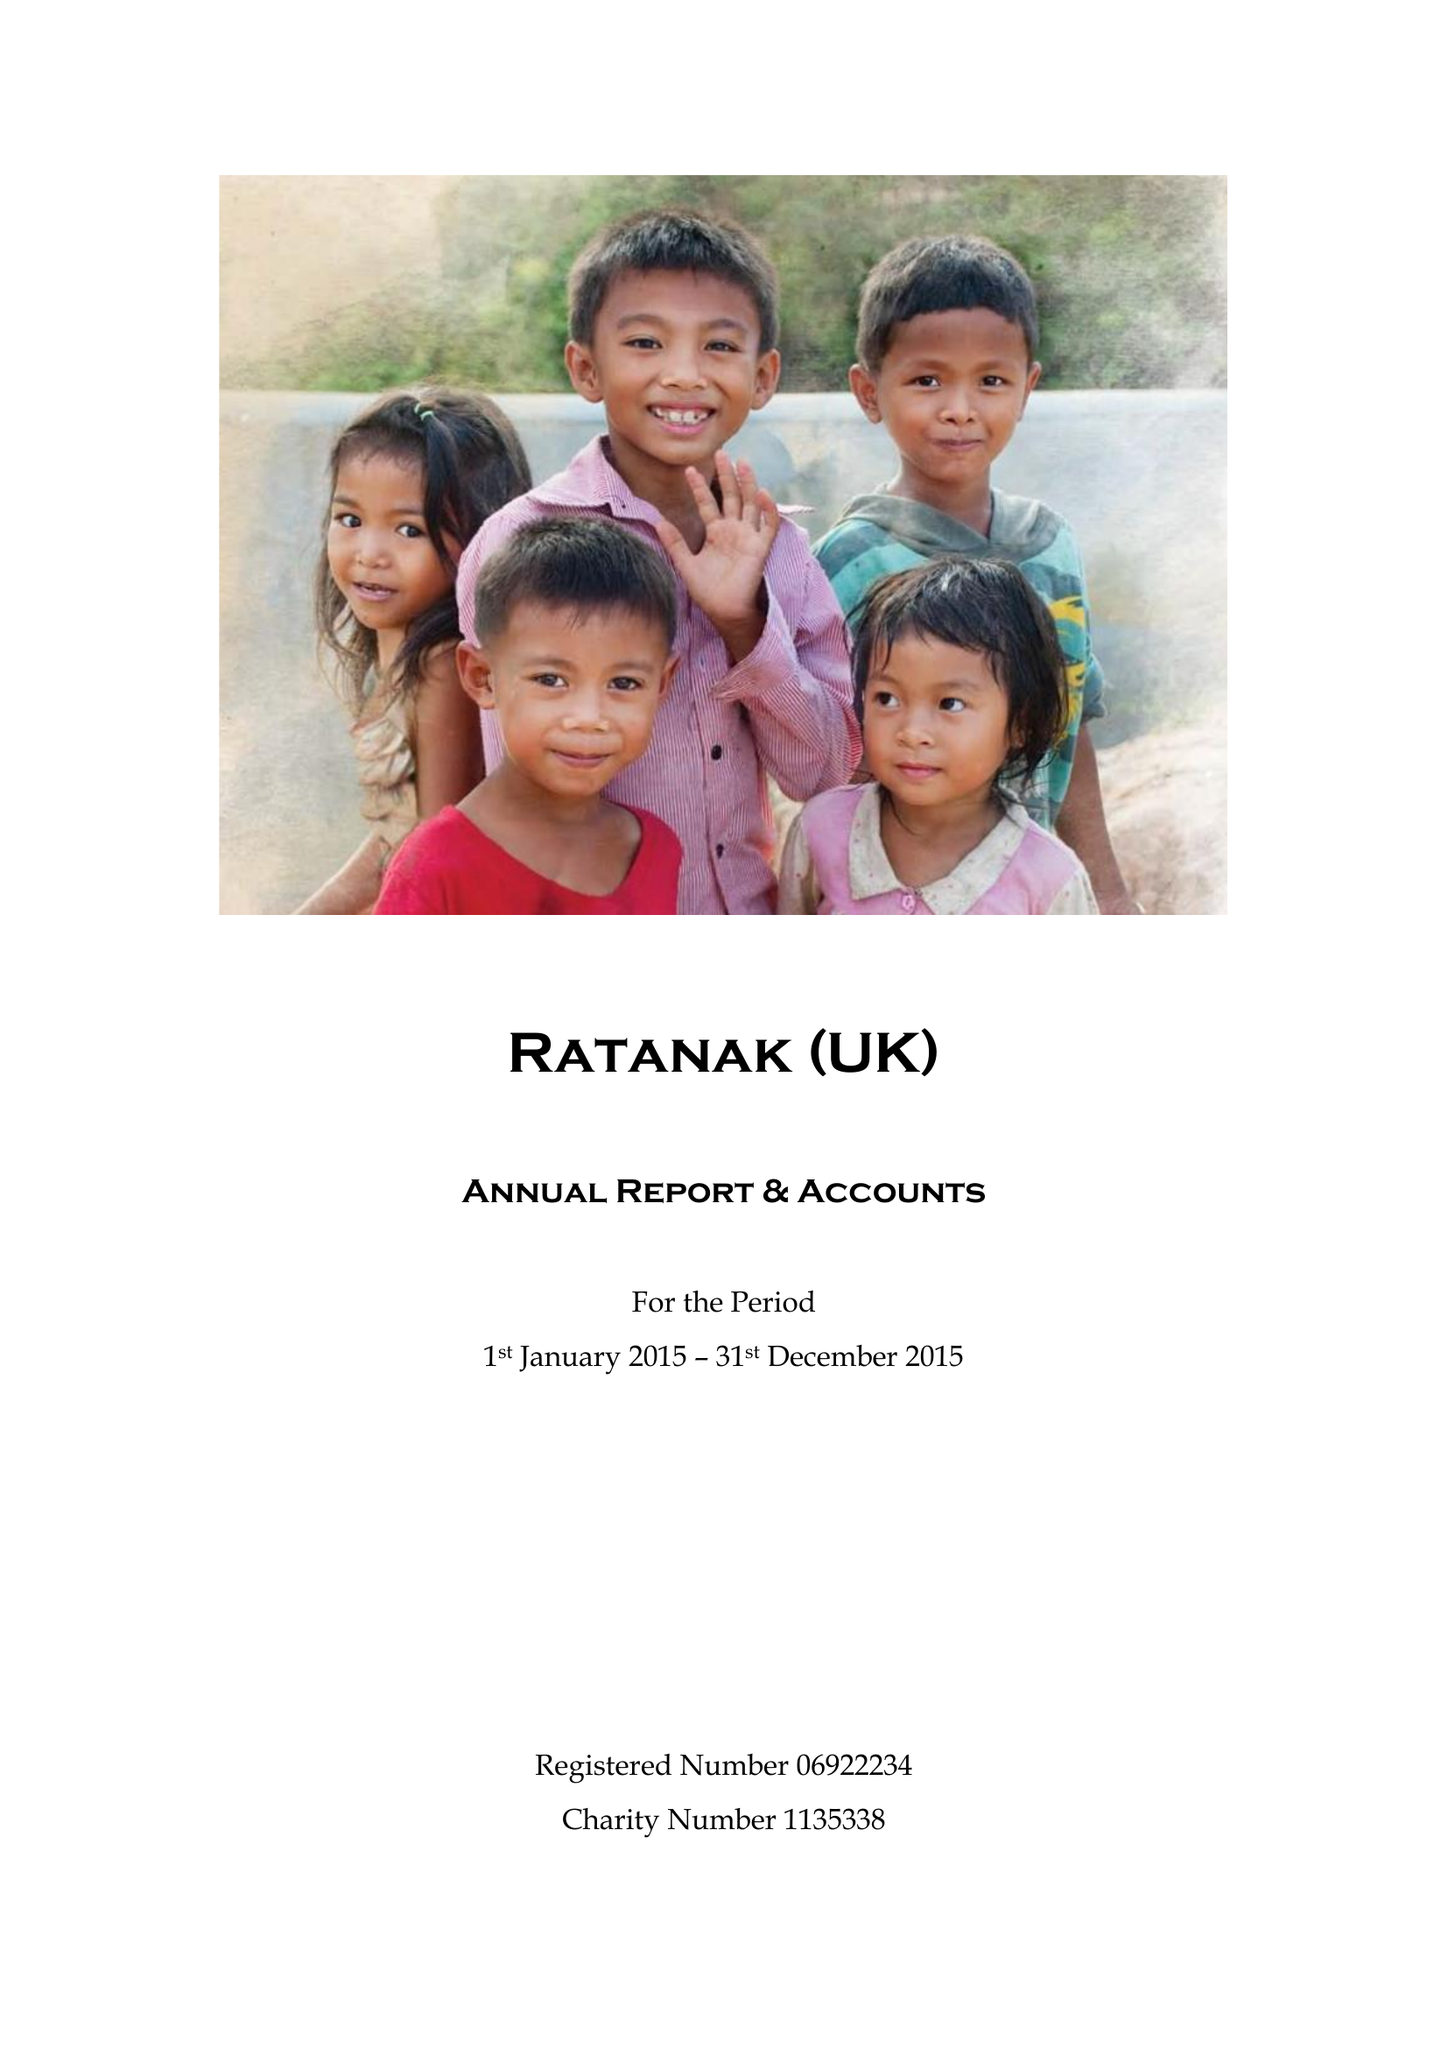What is the value for the report_date?
Answer the question using a single word or phrase. 2015-12-31 